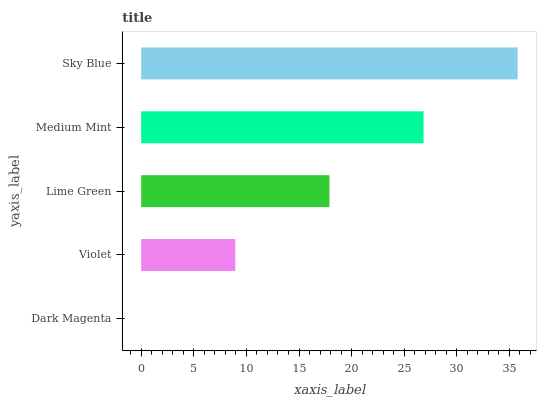Is Dark Magenta the minimum?
Answer yes or no. Yes. Is Sky Blue the maximum?
Answer yes or no. Yes. Is Violet the minimum?
Answer yes or no. No. Is Violet the maximum?
Answer yes or no. No. Is Violet greater than Dark Magenta?
Answer yes or no. Yes. Is Dark Magenta less than Violet?
Answer yes or no. Yes. Is Dark Magenta greater than Violet?
Answer yes or no. No. Is Violet less than Dark Magenta?
Answer yes or no. No. Is Lime Green the high median?
Answer yes or no. Yes. Is Lime Green the low median?
Answer yes or no. Yes. Is Medium Mint the high median?
Answer yes or no. No. Is Medium Mint the low median?
Answer yes or no. No. 